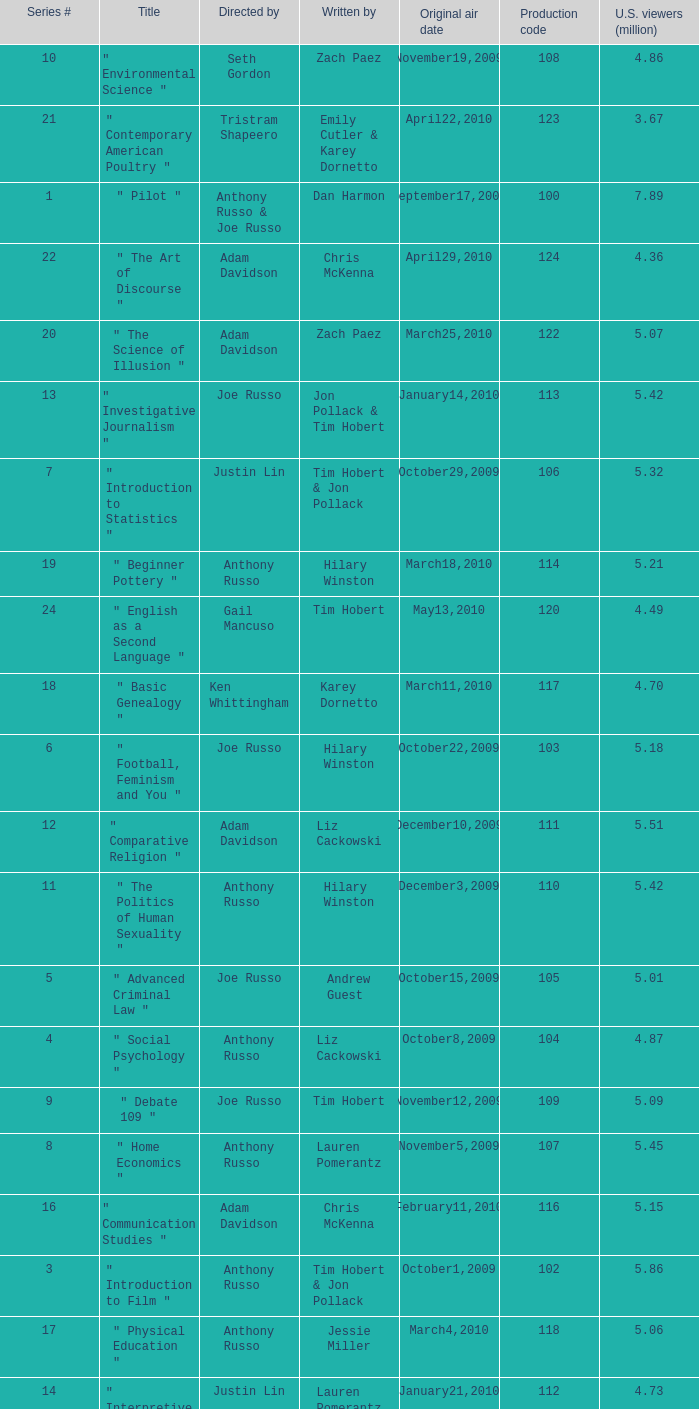What is the original air date when the u.s. viewers in millions was 5.39? September24,2009. 